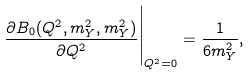Convert formula to latex. <formula><loc_0><loc_0><loc_500><loc_500>\frac { \partial B _ { 0 } ( Q ^ { 2 } , m _ { Y } ^ { 2 } , m _ { Y } ^ { 2 } ) } { \partial Q ^ { 2 } } \Big | _ { Q ^ { 2 } = 0 } = \frac { 1 } { 6 m _ { Y } ^ { 2 } } ,</formula> 